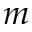<formula> <loc_0><loc_0><loc_500><loc_500>m</formula> 